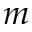<formula> <loc_0><loc_0><loc_500><loc_500>m</formula> 